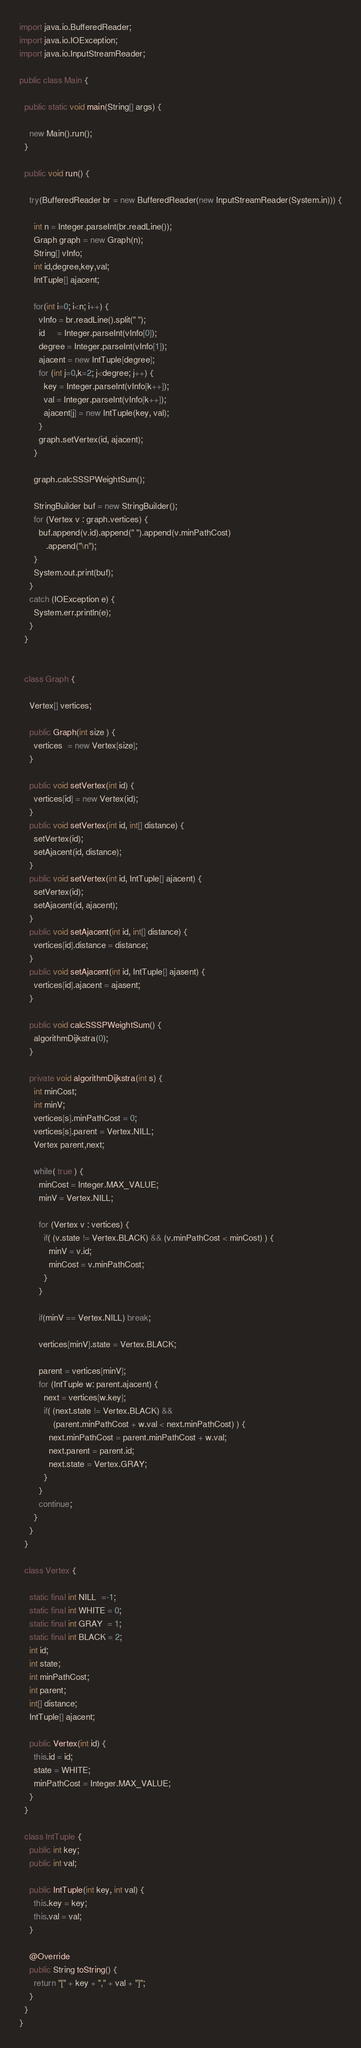<code> <loc_0><loc_0><loc_500><loc_500><_Java_>import java.io.BufferedReader;
import java.io.IOException;
import java.io.InputStreamReader;

public class Main {

  public static void main(String[] args) {
    
    new Main().run();
  }

  public void run() {

    try(BufferedReader br = new BufferedReader(new InputStreamReader(System.in))) {

      int n = Integer.parseInt(br.readLine());
      Graph graph = new Graph(n);
      String[] vInfo;
      int id,degree,key,val;
      IntTuple[] ajacent;

      for(int i=0; i<n; i++) {
        vInfo = br.readLine().split(" ");
        id     = Integer.parseInt(vInfo[0]);
        degree = Integer.parseInt(vInfo[1]);
        ajacent = new IntTuple[degree];
        for (int j=0,k=2; j<degree; j++) {
          key = Integer.parseInt(vInfo[k++]);
          val = Integer.parseInt(vInfo[k++]);
          ajacent[j] = new IntTuple(key, val);
        }
        graph.setVertex(id, ajacent);
      }

      graph.calcSSSPWeightSum();

      StringBuilder buf = new StringBuilder();
      for (Vertex v : graph.vertices) {
        buf.append(v.id).append(" ").append(v.minPathCost)
           .append("\n");
      }
      System.out.print(buf);
    }
    catch (IOException e) {
      System.err.println(e);
    }
  }


  class Graph {

    Vertex[] vertices;

    public Graph(int size ) {
      vertices  = new Vertex[size];
    }

    public void setVertex(int id) {
      vertices[id] = new Vertex(id);
    }
    public void setVertex(int id, int[] distance) {
      setVertex(id);
      setAjacent(id, distance);
    }
    public void setVertex(int id, IntTuple[] ajacent) {
      setVertex(id);
      setAjacent(id, ajacent);
    }
    public void setAjacent(int id, int[] distance) {
      vertices[id].distance = distance;
    }
    public void setAjacent(int id, IntTuple[] ajasent) {
      vertices[id].ajacent = ajasent;
    }

    public void calcSSSPWeightSum() {
      algorithmDijkstra(0);
    }

    private void algorithmDijkstra(int s) {
      int minCost;
      int minV;
      vertices[s].minPathCost = 0;
      vertices[s].parent = Vertex.NILL;
      Vertex parent,next;

      while( true ) {
        minCost = Integer.MAX_VALUE;
        minV = Vertex.NILL;

        for (Vertex v : vertices) {
          if( (v.state != Vertex.BLACK) && (v.minPathCost < minCost) ) {
            minV = v.id;
            minCost = v.minPathCost;
          }
        }

        if(minV == Vertex.NILL) break;

        vertices[minV].state = Vertex.BLACK;

        parent = vertices[minV];
        for (IntTuple w: parent.ajacent) {
          next = vertices[w.key];
          if( (next.state != Vertex.BLACK) &&
              (parent.minPathCost + w.val < next.minPathCost) ) {
            next.minPathCost = parent.minPathCost + w.val;
            next.parent = parent.id;
            next.state = Vertex.GRAY;
          }
        }
        continue;
      }
    }
  }

  class Vertex {

    static final int NILL  =-1;
    static final int WHITE = 0;
    static final int GRAY  = 1;
    static final int BLACK = 2;
    int id;
    int state;
    int minPathCost;
    int parent;
    int[] distance;
    IntTuple[] ajacent;

    public Vertex(int id) {
      this.id = id;
      state = WHITE;
      minPathCost = Integer.MAX_VALUE;
    }
  }

  class IntTuple {
    public int key;
    public int val;

    public IntTuple(int key, int val) {
      this.key = key;
      this.val = val;
    }

    @Override
    public String toString() {
      return "[" + key + "," + val + "]";
    }
  }
}
</code> 